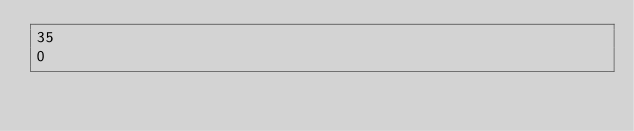Convert code to text. <code><loc_0><loc_0><loc_500><loc_500><_SQL_>35
0</code> 